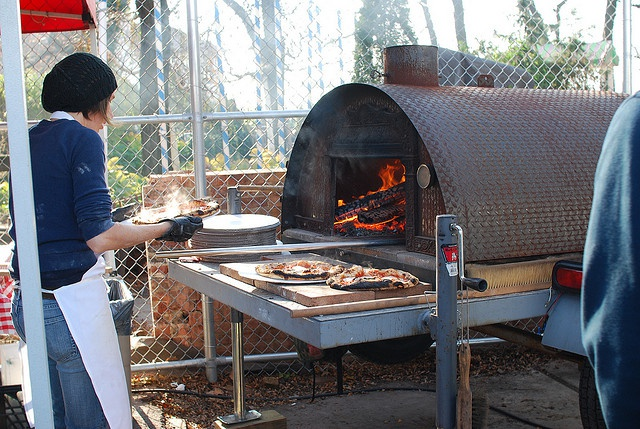Describe the objects in this image and their specific colors. I can see people in lightblue, navy, black, and lavender tones, oven in lightblue, black, maroon, and brown tones, pizza in lightblue, ivory, darkgray, and tan tones, pizza in lightblue, black, ivory, brown, and tan tones, and pizza in lightblue, white, tan, and darkgray tones in this image. 